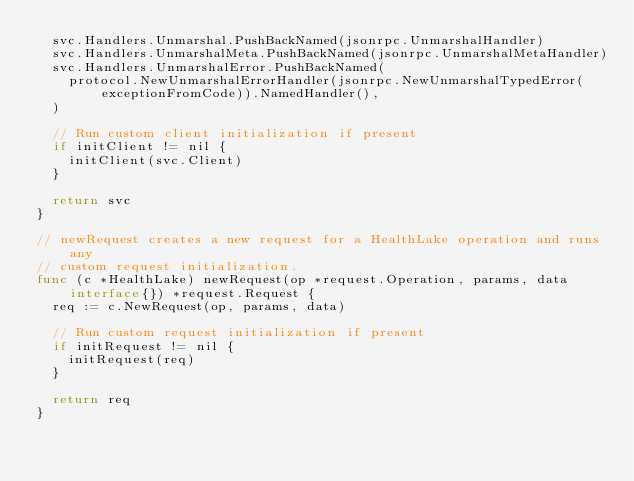<code> <loc_0><loc_0><loc_500><loc_500><_Go_>	svc.Handlers.Unmarshal.PushBackNamed(jsonrpc.UnmarshalHandler)
	svc.Handlers.UnmarshalMeta.PushBackNamed(jsonrpc.UnmarshalMetaHandler)
	svc.Handlers.UnmarshalError.PushBackNamed(
		protocol.NewUnmarshalErrorHandler(jsonrpc.NewUnmarshalTypedError(exceptionFromCode)).NamedHandler(),
	)

	// Run custom client initialization if present
	if initClient != nil {
		initClient(svc.Client)
	}

	return svc
}

// newRequest creates a new request for a HealthLake operation and runs any
// custom request initialization.
func (c *HealthLake) newRequest(op *request.Operation, params, data interface{}) *request.Request {
	req := c.NewRequest(op, params, data)

	// Run custom request initialization if present
	if initRequest != nil {
		initRequest(req)
	}

	return req
}
</code> 